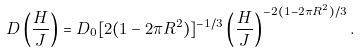Convert formula to latex. <formula><loc_0><loc_0><loc_500><loc_500>D \left ( \frac { H } { J } \right ) = D _ { 0 } [ 2 ( 1 - 2 \pi R ^ { 2 } ) ] ^ { - 1 / 3 } \left ( \frac { H } { J } \right ) ^ { - 2 ( 1 - 2 \pi R ^ { 2 } ) / 3 } .</formula> 